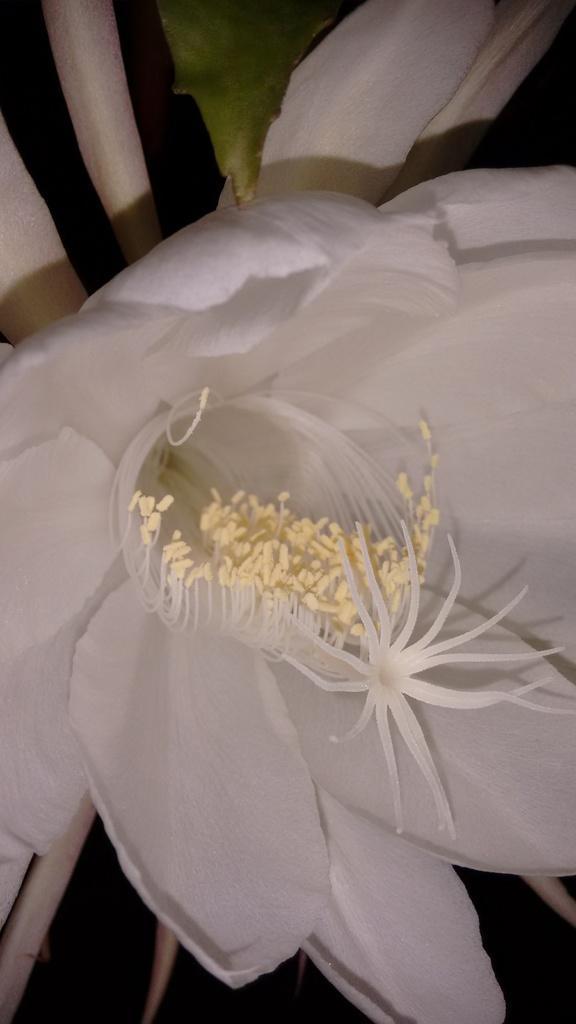How would you summarize this image in a sentence or two? In the center of this picture we can see a white color objects seems to be the flowers. In the background there is a green color object seems to be the leaf. 